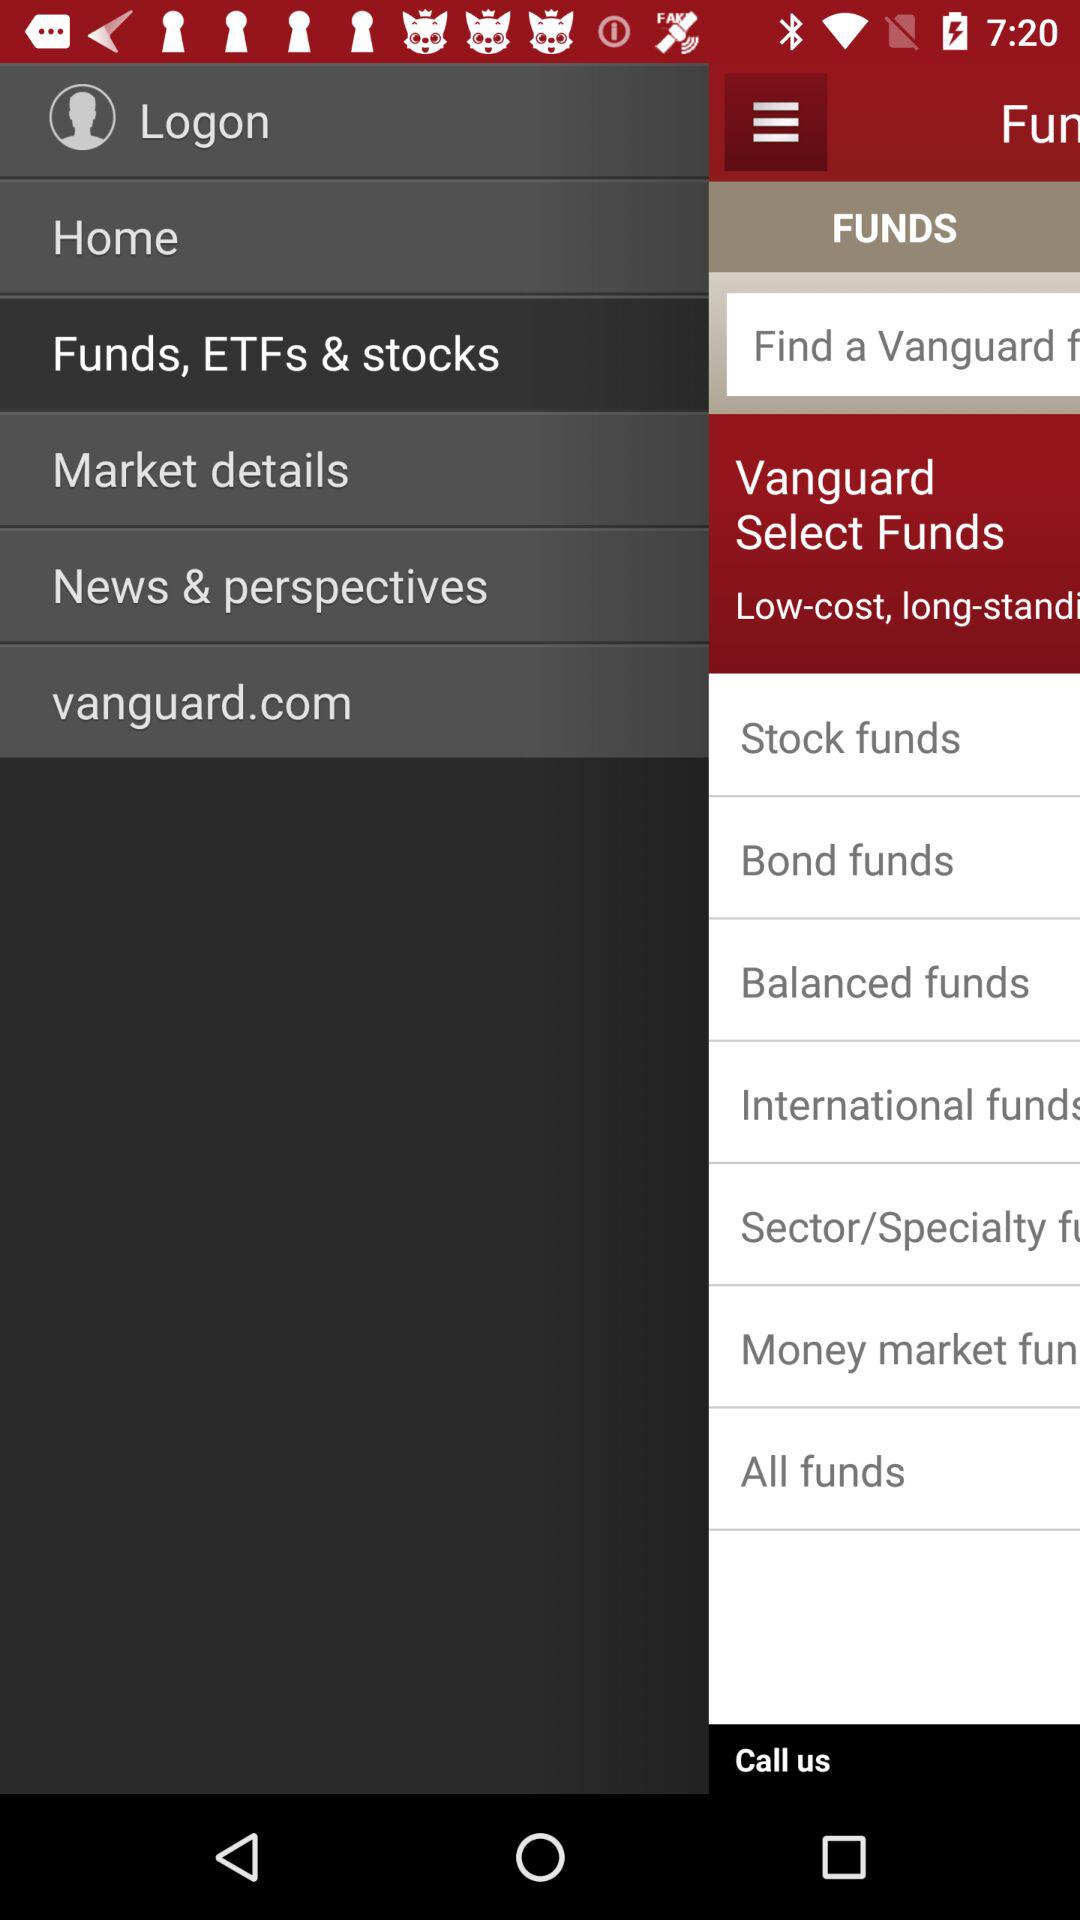What's the User Profile Name?
When the provided information is insufficient, respond with <no answer>. <no answer> 